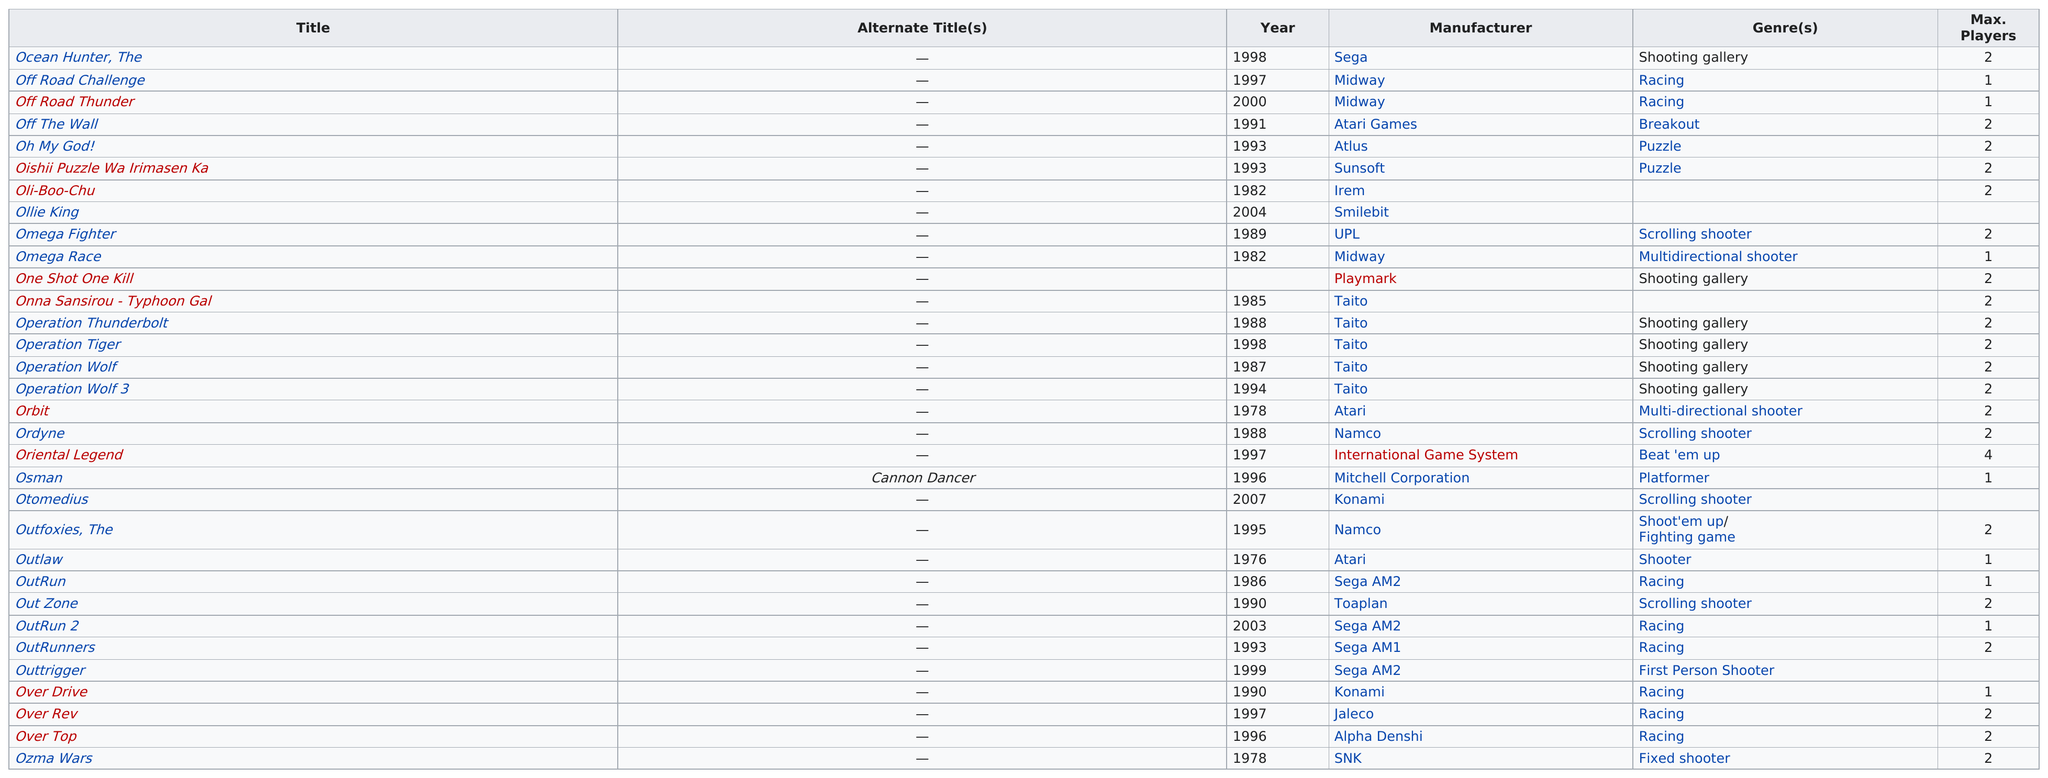Highlight a few significant elements in this photo. I want to know the number of games that have a maximum player limit of at least 3 Taito is the manufacturer with the most games on the list. For 23 years, Atari has been manufacturing the game 'Off the Wall'. One Shot One Kill is the subsequent title listed after Omega Race. What is the maximum number of players that can participate in a game of 'Outlaw'? The answer is 1. 